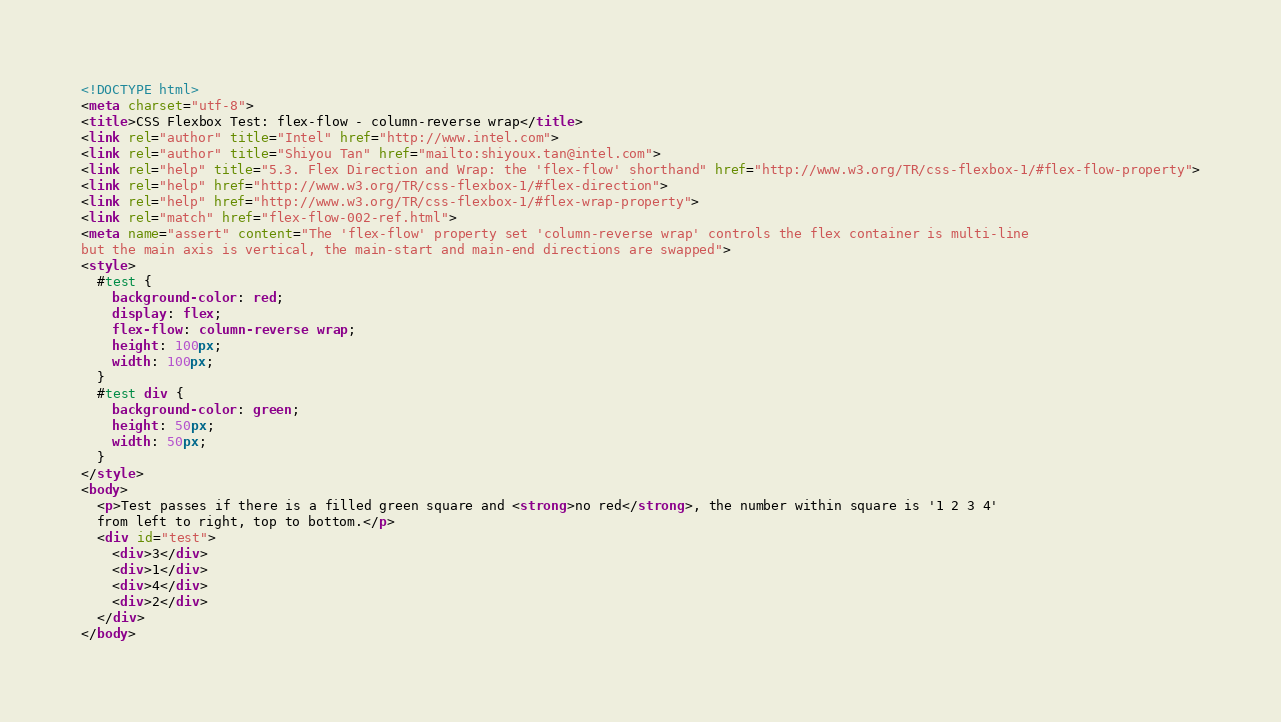Convert code to text. <code><loc_0><loc_0><loc_500><loc_500><_HTML_><!DOCTYPE html>
<meta charset="utf-8">
<title>CSS Flexbox Test: flex-flow - column-reverse wrap</title>
<link rel="author" title="Intel" href="http://www.intel.com">
<link rel="author" title="Shiyou Tan" href="mailto:shiyoux.tan@intel.com">
<link rel="help" title="5.3. Flex Direction and Wrap: the 'flex-flow' shorthand" href="http://www.w3.org/TR/css-flexbox-1/#flex-flow-property">
<link rel="help" href="http://www.w3.org/TR/css-flexbox-1/#flex-direction">
<link rel="help" href="http://www.w3.org/TR/css-flexbox-1/#flex-wrap-property">
<link rel="match" href="flex-flow-002-ref.html">
<meta name="assert" content="The 'flex-flow' property set 'column-reverse wrap' controls the flex container is multi-line
but the main axis is vertical, the main-start and main-end directions are swapped">
<style>
  #test {
    background-color: red;
    display: flex;
    flex-flow: column-reverse wrap;
    height: 100px;
    width: 100px;
  }
  #test div {
    background-color: green;
    height: 50px;
    width: 50px;
  }
</style>
<body>
  <p>Test passes if there is a filled green square and <strong>no red</strong>, the number within square is '1 2 3 4'
  from left to right, top to bottom.</p>
  <div id="test">
    <div>3</div>
    <div>1</div>
    <div>4</div>
    <div>2</div>
  </div>
</body>
</code> 